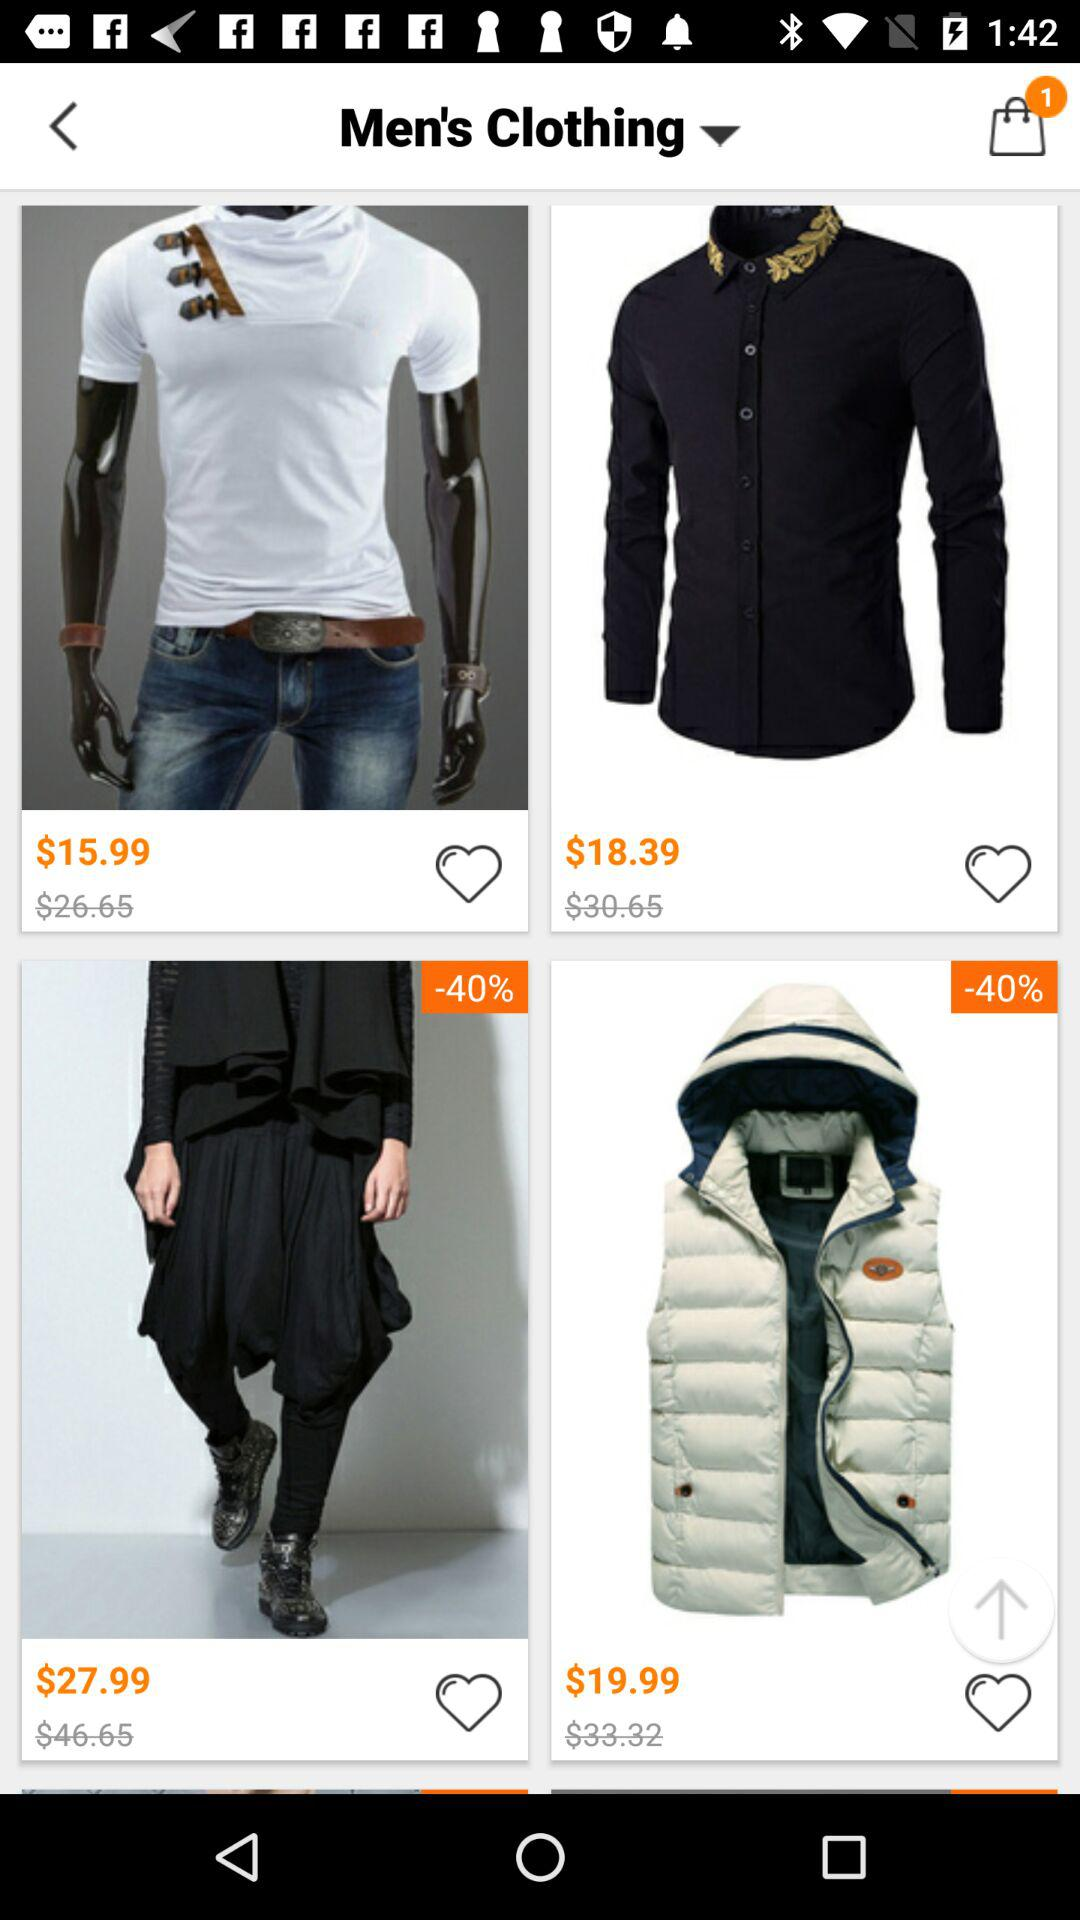How many items are in the cart? There is one item in the cart. 